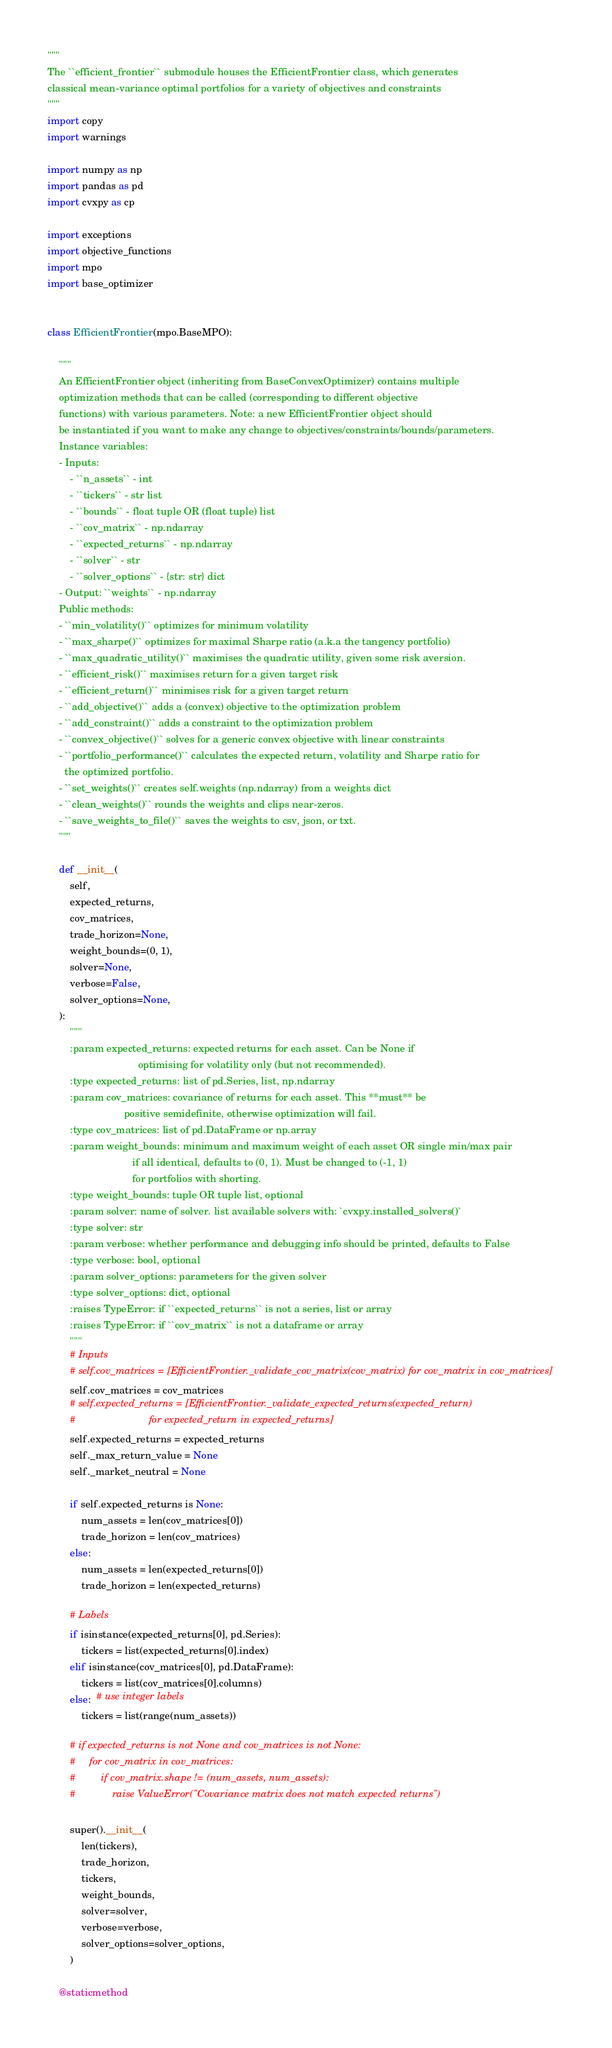Convert code to text. <code><loc_0><loc_0><loc_500><loc_500><_Python_>"""
The ``efficient_frontier`` submodule houses the EfficientFrontier class, which generates
classical mean-variance optimal portfolios for a variety of objectives and constraints
"""
import copy
import warnings

import numpy as np
import pandas as pd
import cvxpy as cp

import exceptions
import objective_functions
import mpo
import base_optimizer


class EfficientFrontier(mpo.BaseMPO):

    """
    An EfficientFrontier object (inheriting from BaseConvexOptimizer) contains multiple
    optimization methods that can be called (corresponding to different objective
    functions) with various parameters. Note: a new EfficientFrontier object should
    be instantiated if you want to make any change to objectives/constraints/bounds/parameters.
    Instance variables:
    - Inputs:
        - ``n_assets`` - int
        - ``tickers`` - str list
        - ``bounds`` - float tuple OR (float tuple) list
        - ``cov_matrix`` - np.ndarray
        - ``expected_returns`` - np.ndarray
        - ``solver`` - str
        - ``solver_options`` - {str: str} dict
    - Output: ``weights`` - np.ndarray
    Public methods:
    - ``min_volatility()`` optimizes for minimum volatility
    - ``max_sharpe()`` optimizes for maximal Sharpe ratio (a.k.a the tangency portfolio)
    - ``max_quadratic_utility()`` maximises the quadratic utility, given some risk aversion.
    - ``efficient_risk()`` maximises return for a given target risk
    - ``efficient_return()`` minimises risk for a given target return
    - ``add_objective()`` adds a (convex) objective to the optimization problem
    - ``add_constraint()`` adds a constraint to the optimization problem
    - ``convex_objective()`` solves for a generic convex objective with linear constraints
    - ``portfolio_performance()`` calculates the expected return, volatility and Sharpe ratio for
      the optimized portfolio.
    - ``set_weights()`` creates self.weights (np.ndarray) from a weights dict
    - ``clean_weights()`` rounds the weights and clips near-zeros.
    - ``save_weights_to_file()`` saves the weights to csv, json, or txt.
    """

    def __init__(
        self,
        expected_returns,
        cov_matrices,
        trade_horizon=None,
        weight_bounds=(0, 1),
        solver=None,
        verbose=False,
        solver_options=None,
    ):
        """
        :param expected_returns: expected returns for each asset. Can be None if
                                optimising for volatility only (but not recommended).
        :type expected_returns: list of pd.Series, list, np.ndarray
        :param cov_matrices: covariance of returns for each asset. This **must** be
                           positive semidefinite, otherwise optimization will fail.
        :type cov_matrices: list of pd.DataFrame or np.array
        :param weight_bounds: minimum and maximum weight of each asset OR single min/max pair
                              if all identical, defaults to (0, 1). Must be changed to (-1, 1)
                              for portfolios with shorting.
        :type weight_bounds: tuple OR tuple list, optional
        :param solver: name of solver. list available solvers with: `cvxpy.installed_solvers()`
        :type solver: str
        :param verbose: whether performance and debugging info should be printed, defaults to False
        :type verbose: bool, optional
        :param solver_options: parameters for the given solver
        :type solver_options: dict, optional
        :raises TypeError: if ``expected_returns`` is not a series, list or array
        :raises TypeError: if ``cov_matrix`` is not a dataframe or array
        """
        # Inputs
        # self.cov_matrices = [EfficientFrontier._validate_cov_matrix(cov_matrix) for cov_matrix in cov_matrices]
        self.cov_matrices = cov_matrices
        # self.expected_returns = [EfficientFrontier._validate_expected_returns(expected_return)
        #                          for expected_return in expected_returns]
        self.expected_returns = expected_returns
        self._max_return_value = None
        self._market_neutral = None

        if self.expected_returns is None:
            num_assets = len(cov_matrices[0])
            trade_horizon = len(cov_matrices)
        else:
            num_assets = len(expected_returns[0])
            trade_horizon = len(expected_returns)

        # Labels
        if isinstance(expected_returns[0], pd.Series):
            tickers = list(expected_returns[0].index)
        elif isinstance(cov_matrices[0], pd.DataFrame):
            tickers = list(cov_matrices[0].columns)
        else:  # use integer labels
            tickers = list(range(num_assets))

        # if expected_returns is not None and cov_matrices is not None:
        #     for cov_matrix in cov_matrices:
        #         if cov_matrix.shape != (num_assets, num_assets):
        #             raise ValueError("Covariance matrix does not match expected returns")

        super().__init__(
            len(tickers),
            trade_horizon,
            tickers,
            weight_bounds,
            solver=solver,
            verbose=verbose,
            solver_options=solver_options,
        )

    @staticmethod</code> 